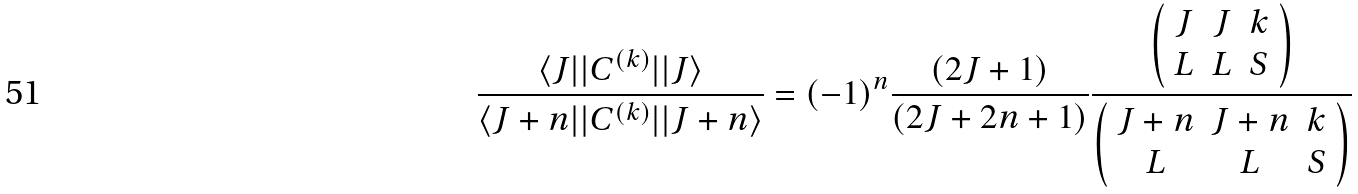Convert formula to latex. <formula><loc_0><loc_0><loc_500><loc_500>\frac { \langle J | | C ^ { ( k ) } | | J \rangle } { \langle J + n | | C ^ { ( k ) } | | J + n \rangle } = ( - 1 ) ^ { n } \frac { ( 2 J + 1 ) } { ( 2 J + 2 n + 1 ) } \frac { \left ( \begin{array} { c c c } J & J & k \\ L & L & S \end{array} \right ) } { \left ( \begin{array} { c c c } J + n & J + n & k \\ L & L & S \end{array} \right ) }</formula> 